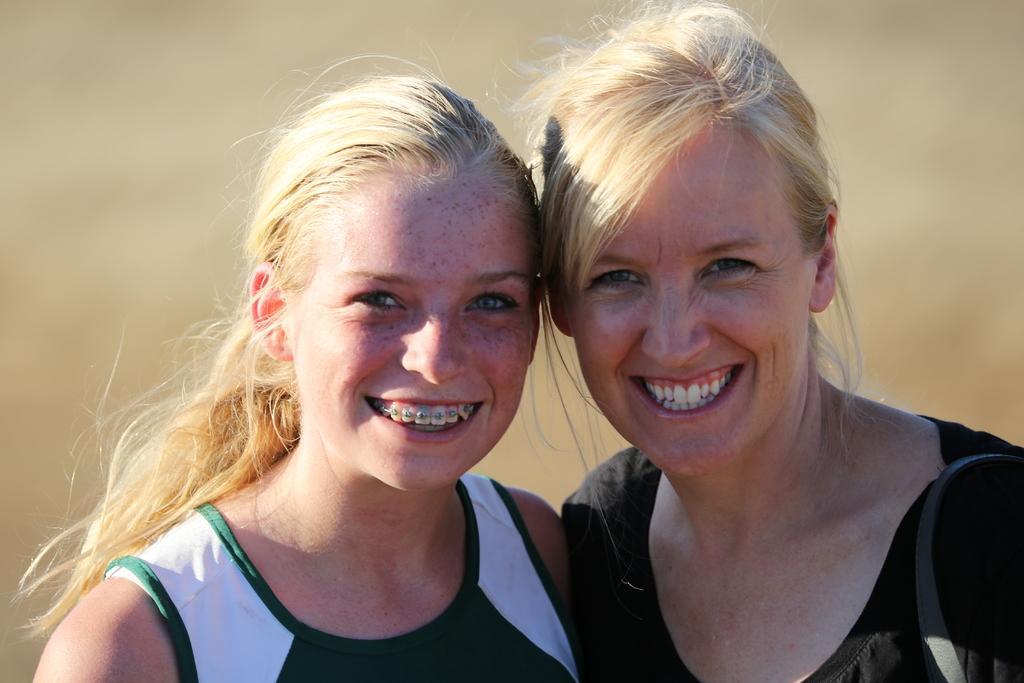Could you give a brief overview of what you see in this image? In this image we can see two ladies, and the background is blurred. 